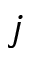Convert formula to latex. <formula><loc_0><loc_0><loc_500><loc_500>j</formula> 